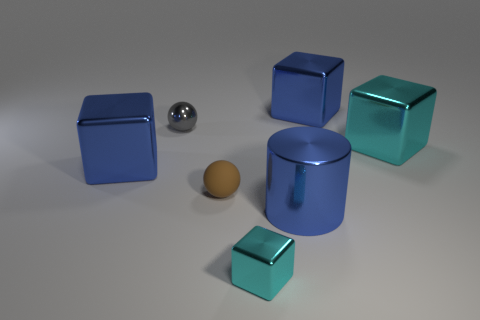What size is the other object that is the same shape as the tiny brown rubber thing?
Your answer should be very brief. Small. There is a large metallic object that is to the left of the big blue shiny thing that is in front of the brown sphere; what shape is it?
Provide a succinct answer. Cube. What is the color of the small rubber object that is the same shape as the gray shiny object?
Your answer should be very brief. Brown. Is the size of the blue thing on the left side of the matte thing the same as the large cyan block?
Your response must be concise. Yes. What shape is the thing that is the same color as the tiny metal cube?
Your answer should be compact. Cube. What number of small objects have the same material as the brown ball?
Provide a succinct answer. 0. The blue thing in front of the big blue block in front of the big blue shiny object that is right of the blue metal cylinder is made of what material?
Your response must be concise. Metal. There is a big thing that is in front of the blue cube left of the blue shiny cylinder; what color is it?
Make the answer very short. Blue. What color is the other ball that is the same size as the brown sphere?
Provide a short and direct response. Gray. How many small things are either brown objects or cyan shiny objects?
Offer a very short reply. 2. 